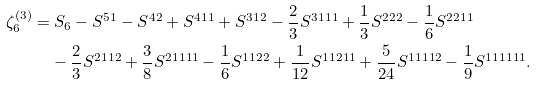Convert formula to latex. <formula><loc_0><loc_0><loc_500><loc_500>\zeta _ { 6 } ^ { ( 3 ) } = & \ S _ { 6 } - S ^ { 5 1 } - S ^ { 4 2 } + S ^ { 4 1 1 } + S ^ { 3 1 2 } - \frac { 2 } { 3 } S ^ { 3 1 1 1 } + \frac { 1 } { 3 } S ^ { 2 2 2 } - \frac { 1 } { 6 } S ^ { 2 2 1 1 } \\ & - \frac { 2 } { 3 } S ^ { 2 1 1 2 } + \frac { 3 } { 8 } S ^ { 2 1 1 1 1 } - \frac { 1 } { 6 } S ^ { 1 1 2 2 } + \frac { 1 } { 1 2 } S ^ { 1 1 2 1 1 } + \frac { 5 } { 2 4 } S ^ { 1 1 1 1 2 } - \frac { 1 } { 9 } S ^ { 1 1 1 1 1 1 } .</formula> 